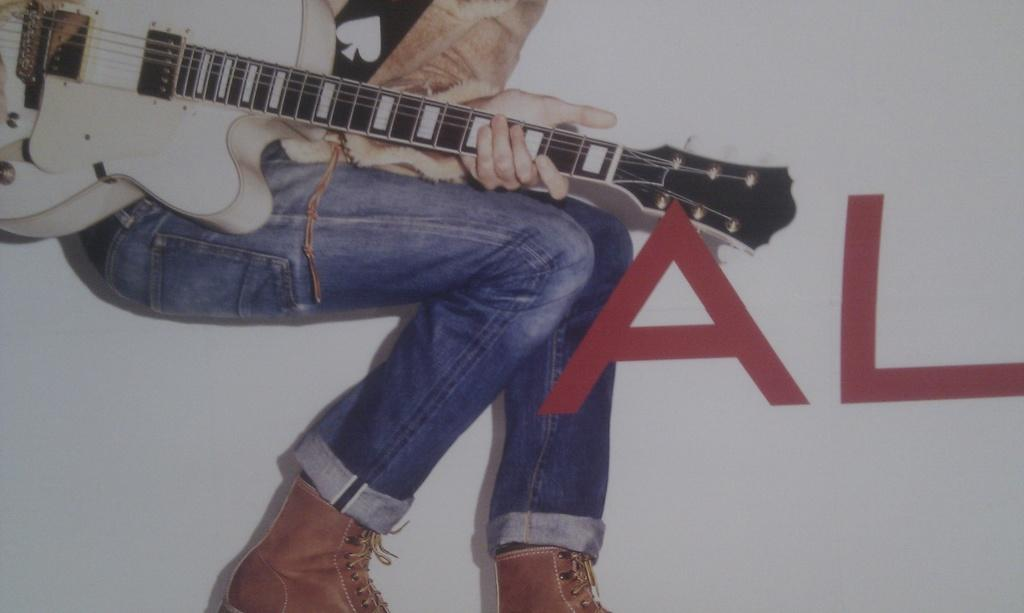What is the main subject of the image? There is a person in the image. What is the person holding in the image? The person is holding a guitar. Can you tell me what the actor's name is in the image? There is no actor mentioned in the image, and the person's name is not provided. Does the person in the image have a tail? There is no indication of a tail on the person in the image. 